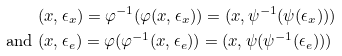Convert formula to latex. <formula><loc_0><loc_0><loc_500><loc_500>& ( x , \epsilon _ { x } ) = \varphi ^ { - 1 } ( \varphi ( x , \epsilon _ { x } ) ) = ( x , \psi ^ { - 1 } ( \psi ( \epsilon _ { x } ) ) ) \\ \text { and } & ( x , \epsilon _ { e } ) = \varphi ( \varphi ^ { - 1 } ( x , \epsilon _ { e } ) ) = ( x , \psi ( \psi ^ { - 1 } ( \epsilon _ { e } ) ) )</formula> 